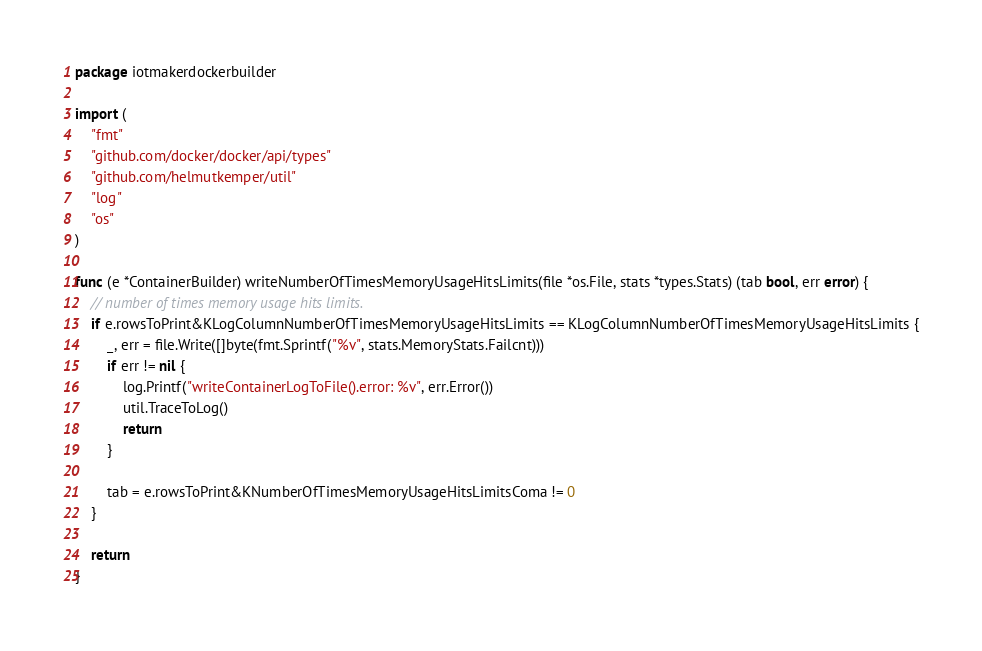Convert code to text. <code><loc_0><loc_0><loc_500><loc_500><_Go_>package iotmakerdockerbuilder

import (
	"fmt"
	"github.com/docker/docker/api/types"
	"github.com/helmutkemper/util"
	"log"
	"os"
)

func (e *ContainerBuilder) writeNumberOfTimesMemoryUsageHitsLimits(file *os.File, stats *types.Stats) (tab bool, err error) {
	// number of times memory usage hits limits.
	if e.rowsToPrint&KLogColumnNumberOfTimesMemoryUsageHitsLimits == KLogColumnNumberOfTimesMemoryUsageHitsLimits {
		_, err = file.Write([]byte(fmt.Sprintf("%v", stats.MemoryStats.Failcnt)))
		if err != nil {
			log.Printf("writeContainerLogToFile().error: %v", err.Error())
			util.TraceToLog()
			return
		}

		tab = e.rowsToPrint&KNumberOfTimesMemoryUsageHitsLimitsComa != 0
	}

	return
}
</code> 